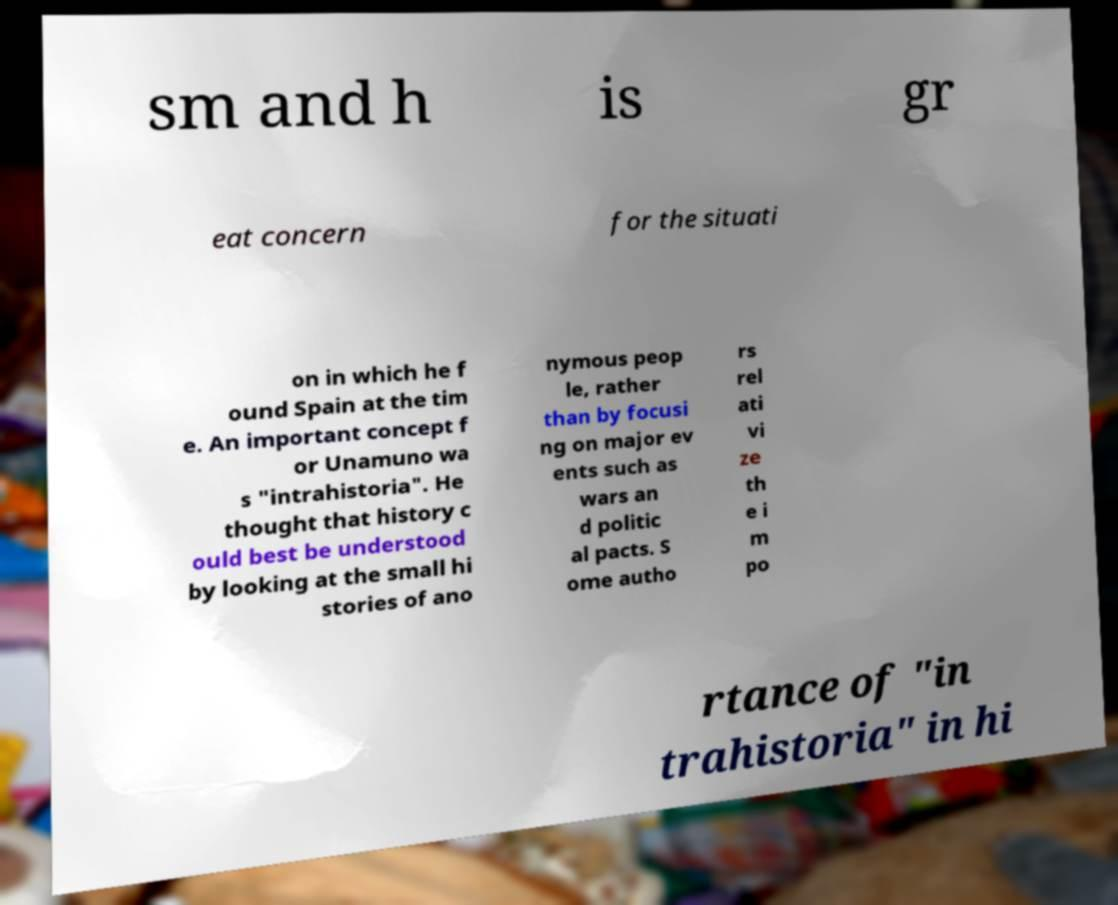I need the written content from this picture converted into text. Can you do that? sm and h is gr eat concern for the situati on in which he f ound Spain at the tim e. An important concept f or Unamuno wa s "intrahistoria". He thought that history c ould best be understood by looking at the small hi stories of ano nymous peop le, rather than by focusi ng on major ev ents such as wars an d politic al pacts. S ome autho rs rel ati vi ze th e i m po rtance of "in trahistoria" in hi 